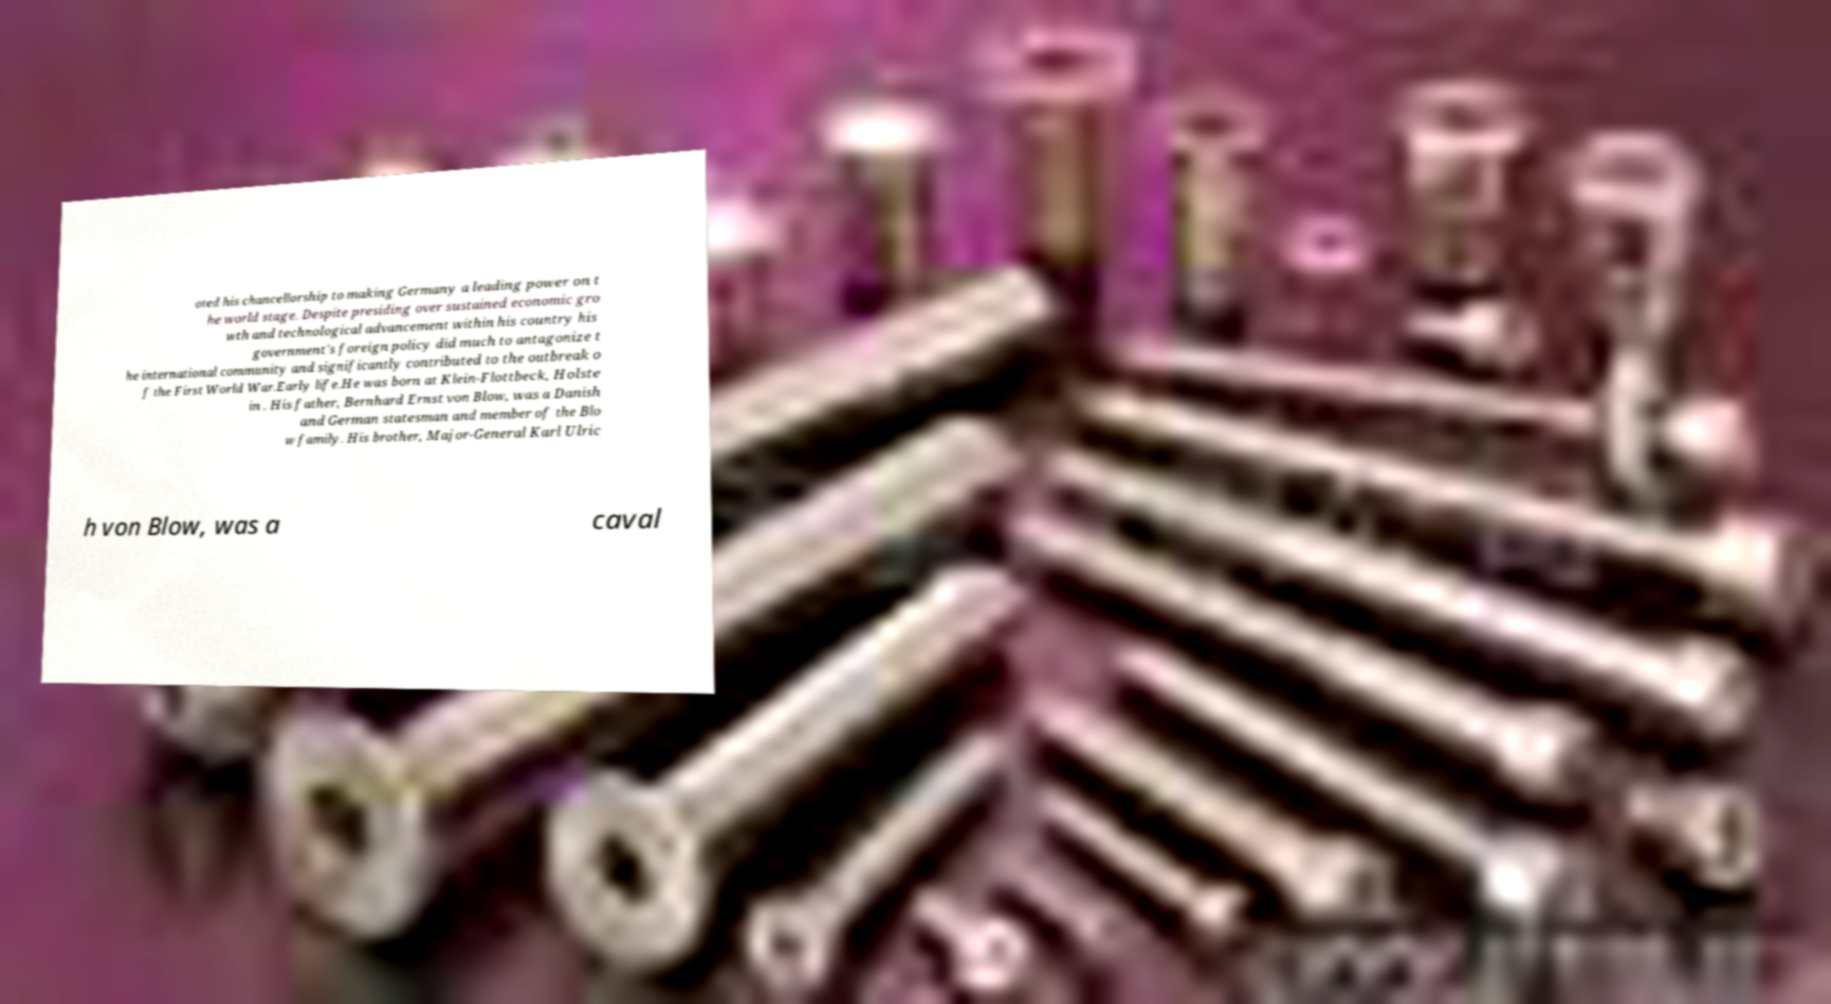Please read and relay the text visible in this image. What does it say? oted his chancellorship to making Germany a leading power on t he world stage. Despite presiding over sustained economic gro wth and technological advancement within his country his government's foreign policy did much to antagonize t he international community and significantly contributed to the outbreak o f the First World War.Early life.He was born at Klein-Flottbeck, Holste in . His father, Bernhard Ernst von Blow, was a Danish and German statesman and member of the Blo w family. His brother, Major-General Karl Ulric h von Blow, was a caval 